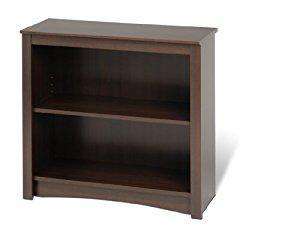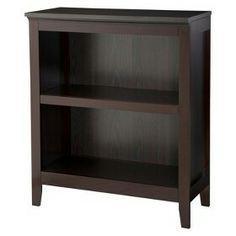The first image is the image on the left, the second image is the image on the right. Assess this claim about the two images: "Two bookcases are wider than they are tall and have two inner shelves, but only one sits flush on the floor.". Correct or not? Answer yes or no. No. The first image is the image on the left, the second image is the image on the right. For the images shown, is this caption "The left and right image contains the same number shelves facing opposite ways." true? Answer yes or no. No. 